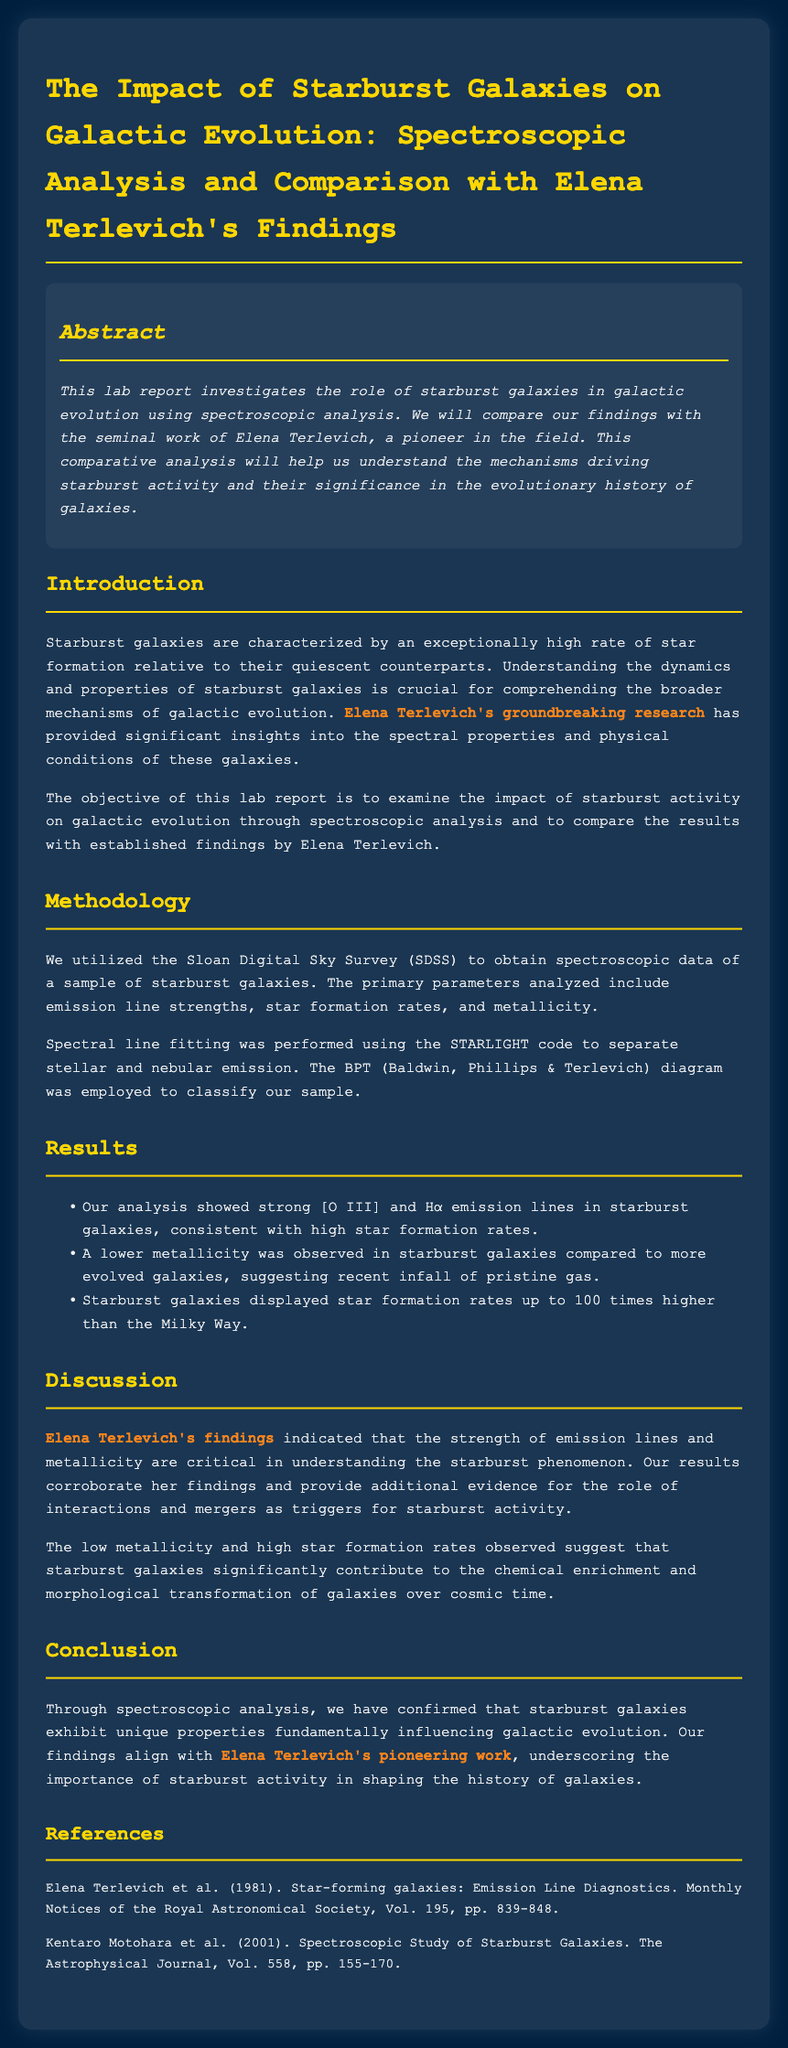What is the title of the lab report? The title of the lab report is stated prominently at the beginning of the document.
Answer: The Impact of Starburst Galaxies on Galactic Evolution: Spectroscopic Analysis and Comparison with Elena Terlevich's Findings Who is the pioneering figure mentioned in the report? The report highlights Elena Terlevich as a significant figure in the study of starburst galaxies.
Answer: Elena Terlevich What method was used to classify the sample of galaxies? The report mentions the usage of the BPT diagram for classification purposes.
Answer: BPT diagram What element showed strong emission lines in starburst galaxies? The results section specifically notes the emission lines observed in the starburst galaxies.
Answer: [O III] and Hα What publication year is referenced for Elena Terlevich's work? The references section includes the publication year of Elena Terlevich's research.
Answer: 1981 How much higher were the star formation rates in starburst galaxies compared to the Milky Way? The results section indicates the comparative magnitude of star formation rates.
Answer: 100 times What phenomenon is primarily discussed in the lab report? The lab report focuses on the role of a specific type of galaxy in galactic evolution.
Answer: Starburst activity What aspect of galaxies does the report suggest starburst galaxies contribute to? The discussion highlights the contributions of starburst galaxies to a specific evolutionary process.
Answer: Chemical enrichment and morphological transformation 